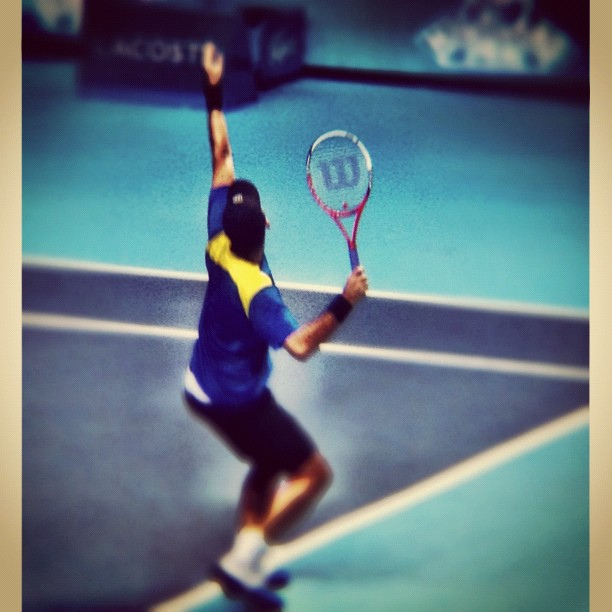Identify the text contained in this image. W 